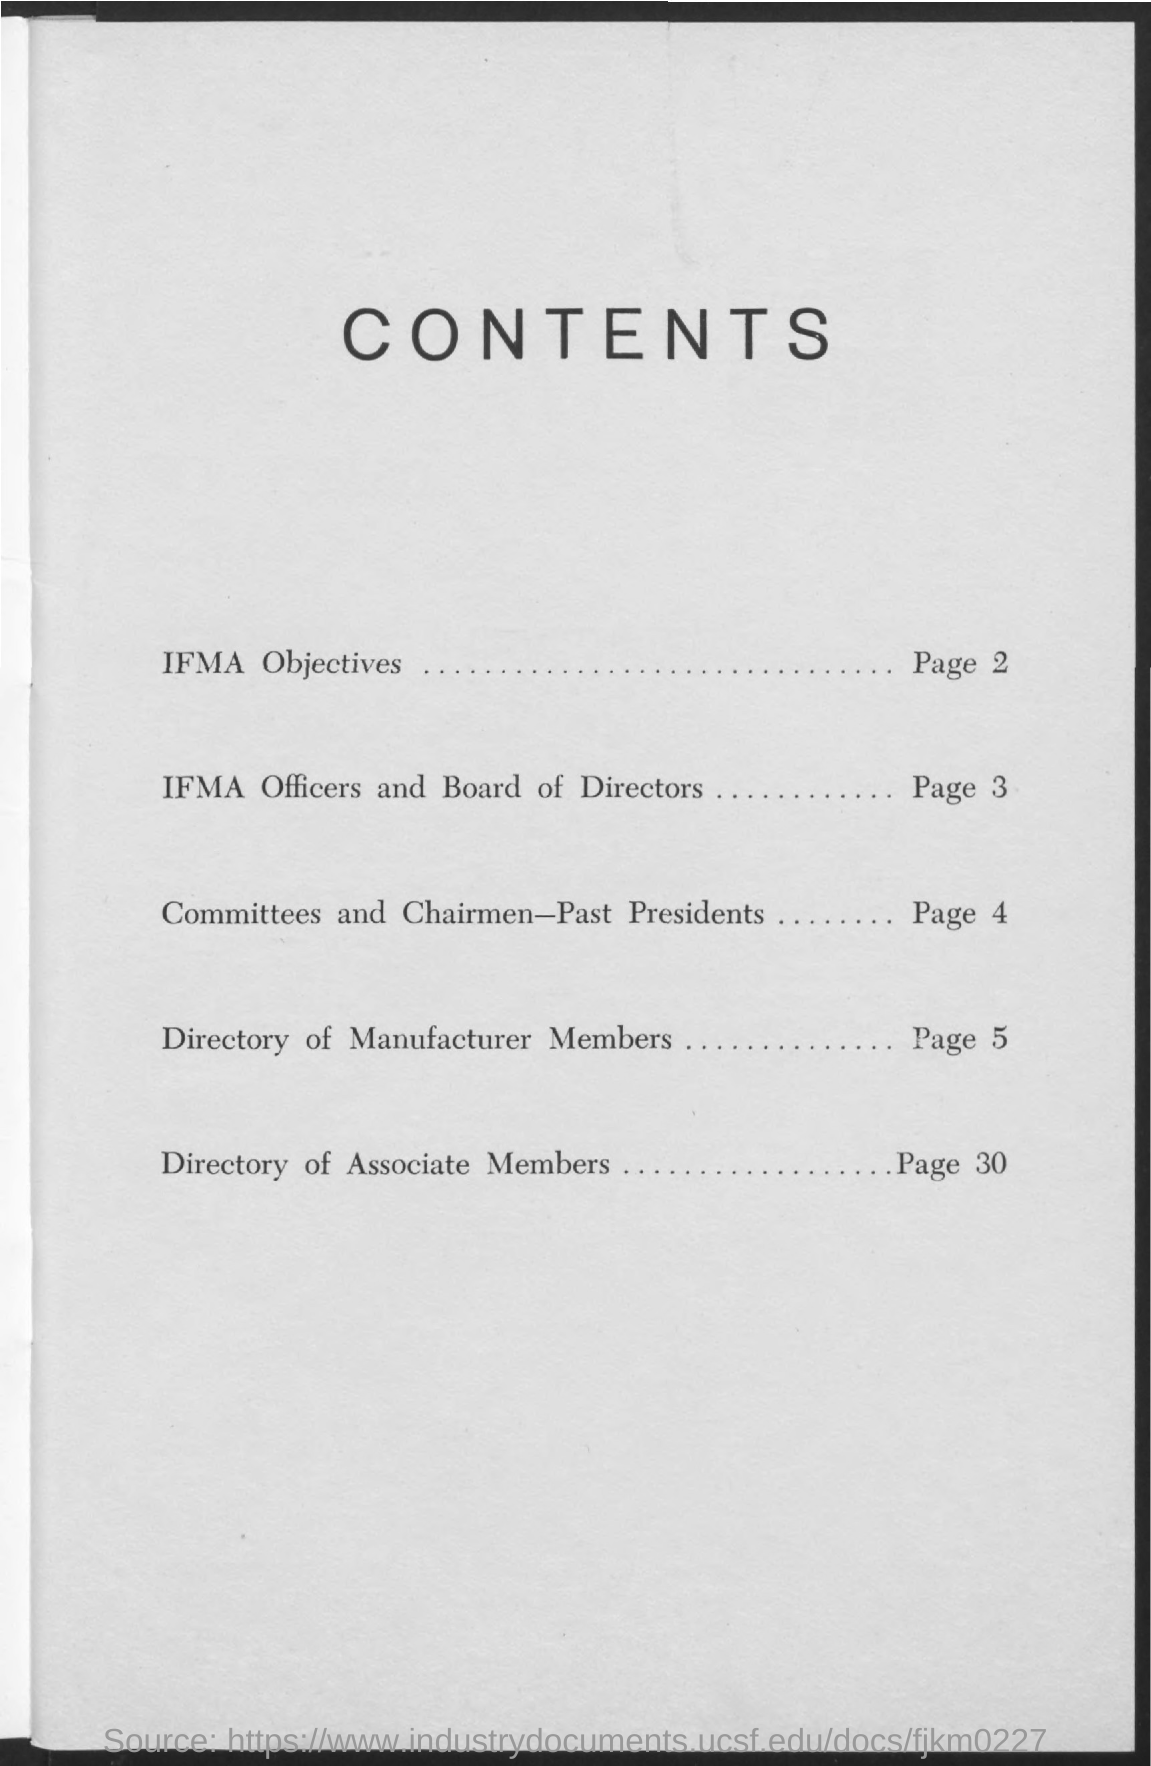Mention a couple of crucial points in this snapshot. The document on page 30 contains a directory of associate members. The contents on page 2 include information about the IFMA objectives. The directory of manufacturer members was provided on page 5. Page 3 contains the list of IFMA officers and board of directors. 